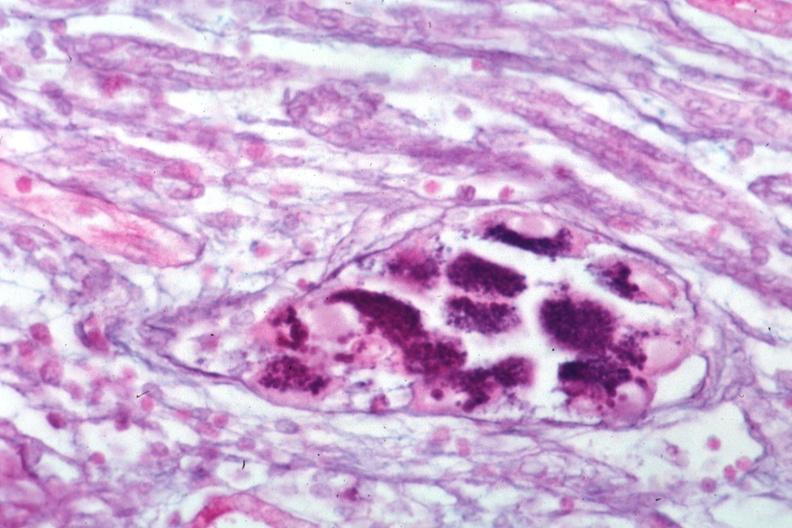what is present?
Answer the question using a single word or phrase. Kidney 